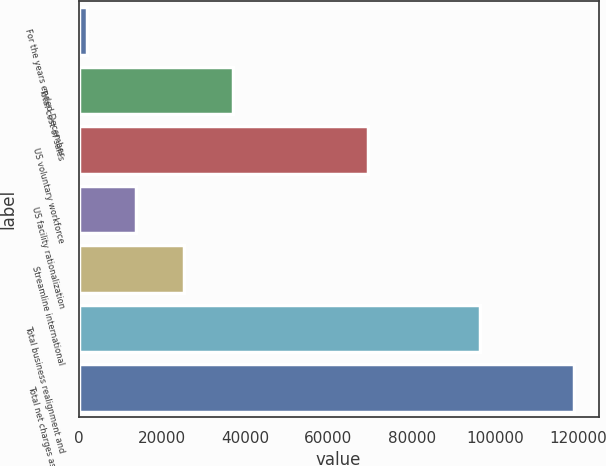<chart> <loc_0><loc_0><loc_500><loc_500><bar_chart><fcel>For the years ended December<fcel>Total cost of sales<fcel>US voluntary workforce<fcel>US facility rationalization<fcel>Streamline international<fcel>Total business realignment and<fcel>Total net charges associated<nl><fcel>2005<fcel>37102.3<fcel>69472<fcel>13704.1<fcel>25403.2<fcel>96537<fcel>118996<nl></chart> 